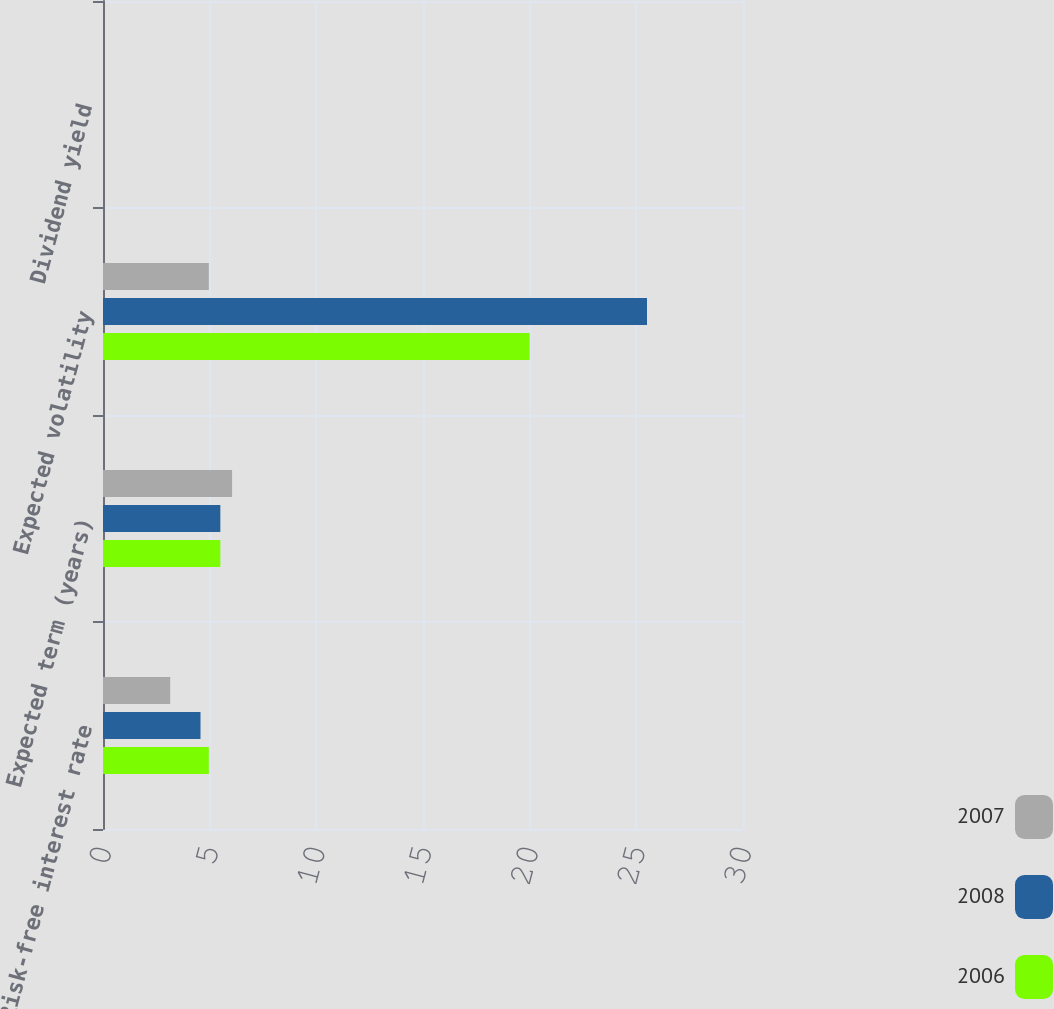Convert chart to OTSL. <chart><loc_0><loc_0><loc_500><loc_500><stacked_bar_chart><ecel><fcel>Risk-free interest rate<fcel>Expected term (years)<fcel>Expected volatility<fcel>Dividend yield<nl><fcel>2007<fcel>3.15<fcel>6.05<fcel>4.96<fcel>0<nl><fcel>2008<fcel>4.57<fcel>5.5<fcel>25.5<fcel>0<nl><fcel>2006<fcel>4.96<fcel>5.5<fcel>20<fcel>0<nl></chart> 